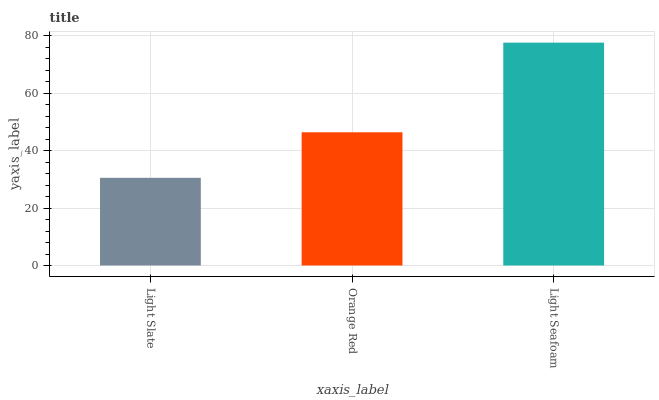Is Light Slate the minimum?
Answer yes or no. Yes. Is Light Seafoam the maximum?
Answer yes or no. Yes. Is Orange Red the minimum?
Answer yes or no. No. Is Orange Red the maximum?
Answer yes or no. No. Is Orange Red greater than Light Slate?
Answer yes or no. Yes. Is Light Slate less than Orange Red?
Answer yes or no. Yes. Is Light Slate greater than Orange Red?
Answer yes or no. No. Is Orange Red less than Light Slate?
Answer yes or no. No. Is Orange Red the high median?
Answer yes or no. Yes. Is Orange Red the low median?
Answer yes or no. Yes. Is Light Seafoam the high median?
Answer yes or no. No. Is Light Slate the low median?
Answer yes or no. No. 